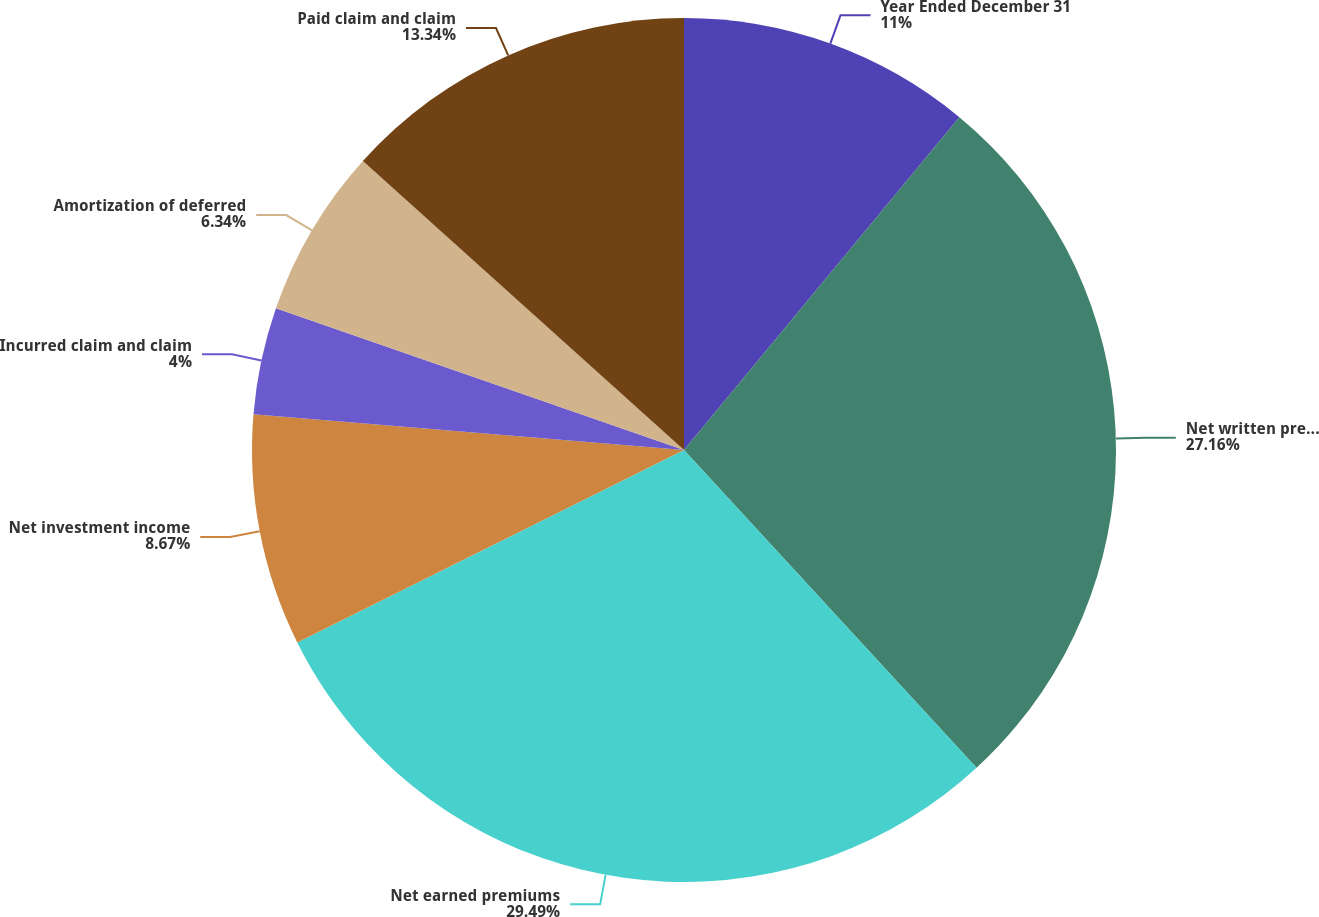Convert chart. <chart><loc_0><loc_0><loc_500><loc_500><pie_chart><fcel>Year Ended December 31<fcel>Net written premiums<fcel>Net earned premiums<fcel>Net investment income<fcel>Incurred claim and claim<fcel>Amortization of deferred<fcel>Paid claim and claim<nl><fcel>11.0%<fcel>27.16%<fcel>29.49%<fcel>8.67%<fcel>4.0%<fcel>6.34%<fcel>13.34%<nl></chart> 